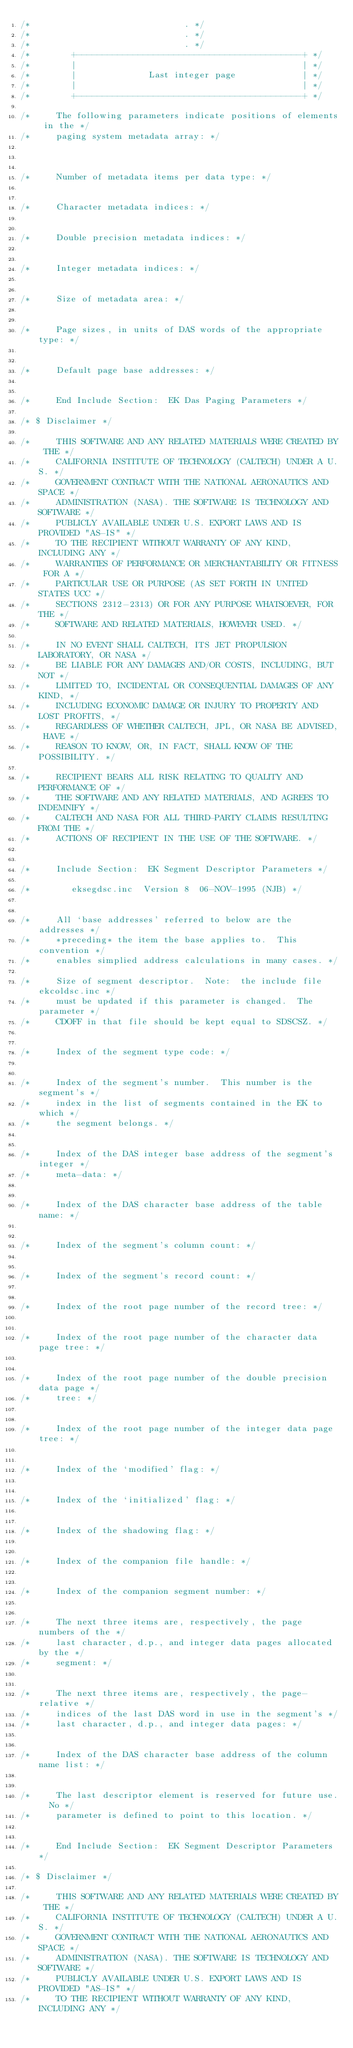Convert code to text. <code><loc_0><loc_0><loc_500><loc_500><_C_>/*                              . */
/*                              . */
/*                              . */
/*        +--------------------------------------------+ */
/*        |                                            | */
/*        |              Last integer page             | */
/*        |                                            | */
/*        +--------------------------------------------+ */

/*     The following parameters indicate positions of elements in the */
/*     paging system metadata array: */



/*     Number of metadata items per data type: */


/*     Character metadata indices: */


/*     Double precision metadata indices: */


/*     Integer metadata indices: */


/*     Size of metadata area: */


/*     Page sizes, in units of DAS words of the appropriate type: */


/*     Default page base addresses: */


/*     End Include Section:  EK Das Paging Parameters */

/* $ Disclaimer */

/*     THIS SOFTWARE AND ANY RELATED MATERIALS WERE CREATED BY THE */
/*     CALIFORNIA INSTITUTE OF TECHNOLOGY (CALTECH) UNDER A U.S. */
/*     GOVERNMENT CONTRACT WITH THE NATIONAL AERONAUTICS AND SPACE */
/*     ADMINISTRATION (NASA). THE SOFTWARE IS TECHNOLOGY AND SOFTWARE */
/*     PUBLICLY AVAILABLE UNDER U.S. EXPORT LAWS AND IS PROVIDED "AS-IS" */
/*     TO THE RECIPIENT WITHOUT WARRANTY OF ANY KIND, INCLUDING ANY */
/*     WARRANTIES OF PERFORMANCE OR MERCHANTABILITY OR FITNESS FOR A */
/*     PARTICULAR USE OR PURPOSE (AS SET FORTH IN UNITED STATES UCC */
/*     SECTIONS 2312-2313) OR FOR ANY PURPOSE WHATSOEVER, FOR THE */
/*     SOFTWARE AND RELATED MATERIALS, HOWEVER USED. */

/*     IN NO EVENT SHALL CALTECH, ITS JET PROPULSION LABORATORY, OR NASA */
/*     BE LIABLE FOR ANY DAMAGES AND/OR COSTS, INCLUDING, BUT NOT */
/*     LIMITED TO, INCIDENTAL OR CONSEQUENTIAL DAMAGES OF ANY KIND, */
/*     INCLUDING ECONOMIC DAMAGE OR INJURY TO PROPERTY AND LOST PROFITS, */
/*     REGARDLESS OF WHETHER CALTECH, JPL, OR NASA BE ADVISED, HAVE */
/*     REASON TO KNOW, OR, IN FACT, SHALL KNOW OF THE POSSIBILITY. */

/*     RECIPIENT BEARS ALL RISK RELATING TO QUALITY AND PERFORMANCE OF */
/*     THE SOFTWARE AND ANY RELATED MATERIALS, AND AGREES TO INDEMNIFY */
/*     CALTECH AND NASA FOR ALL THIRD-PARTY CLAIMS RESULTING FROM THE */
/*     ACTIONS OF RECIPIENT IN THE USE OF THE SOFTWARE. */


/*     Include Section:  EK Segment Descriptor Parameters */

/*        eksegdsc.inc  Version 8  06-NOV-1995 (NJB) */


/*     All `base addresses' referred to below are the addresses */
/*     *preceding* the item the base applies to.  This convention */
/*     enables simplied address calculations in many cases. */

/*     Size of segment descriptor.  Note:  the include file ekcoldsc.inc */
/*     must be updated if this parameter is changed.  The parameter */
/*     CDOFF in that file should be kept equal to SDSCSZ. */


/*     Index of the segment type code: */


/*     Index of the segment's number.  This number is the segment's */
/*     index in the list of segments contained in the EK to which */
/*     the segment belongs. */


/*     Index of the DAS integer base address of the segment's integer */
/*     meta-data: */


/*     Index of the DAS character base address of the table name: */


/*     Index of the segment's column count: */


/*     Index of the segment's record count: */


/*     Index of the root page number of the record tree: */


/*     Index of the root page number of the character data page tree: */


/*     Index of the root page number of the double precision data page */
/*     tree: */


/*     Index of the root page number of the integer data page tree: */


/*     Index of the `modified' flag: */


/*     Index of the `initialized' flag: */


/*     Index of the shadowing flag: */


/*     Index of the companion file handle: */


/*     Index of the companion segment number: */


/*     The next three items are, respectively, the page numbers of the */
/*     last character, d.p., and integer data pages allocated by the */
/*     segment: */


/*     The next three items are, respectively, the page-relative */
/*     indices of the last DAS word in use in the segment's */
/*     last character, d.p., and integer data pages: */


/*     Index of the DAS character base address of the column name list: */


/*     The last descriptor element is reserved for future use.  No */
/*     parameter is defined to point to this location. */


/*     End Include Section:  EK Segment Descriptor Parameters */

/* $ Disclaimer */

/*     THIS SOFTWARE AND ANY RELATED MATERIALS WERE CREATED BY THE */
/*     CALIFORNIA INSTITUTE OF TECHNOLOGY (CALTECH) UNDER A U.S. */
/*     GOVERNMENT CONTRACT WITH THE NATIONAL AERONAUTICS AND SPACE */
/*     ADMINISTRATION (NASA). THE SOFTWARE IS TECHNOLOGY AND SOFTWARE */
/*     PUBLICLY AVAILABLE UNDER U.S. EXPORT LAWS AND IS PROVIDED "AS-IS" */
/*     TO THE RECIPIENT WITHOUT WARRANTY OF ANY KIND, INCLUDING ANY */</code> 